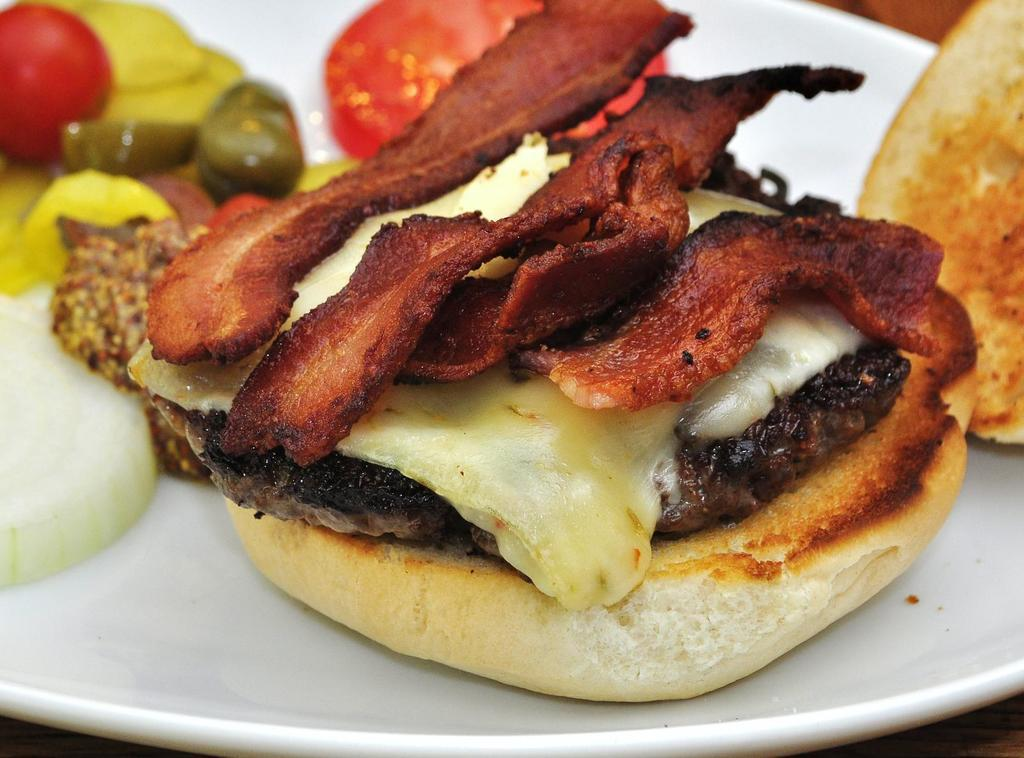What type of items can be seen in the image? There are eatables in the image. How are the eatables arranged or presented? The eatables are placed on a white plate. What type of print can be seen on the jail walls in the image? There is no jail or print present in the image; it only features eatables on a white plate. 